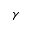Convert formula to latex. <formula><loc_0><loc_0><loc_500><loc_500>\gamma</formula> 